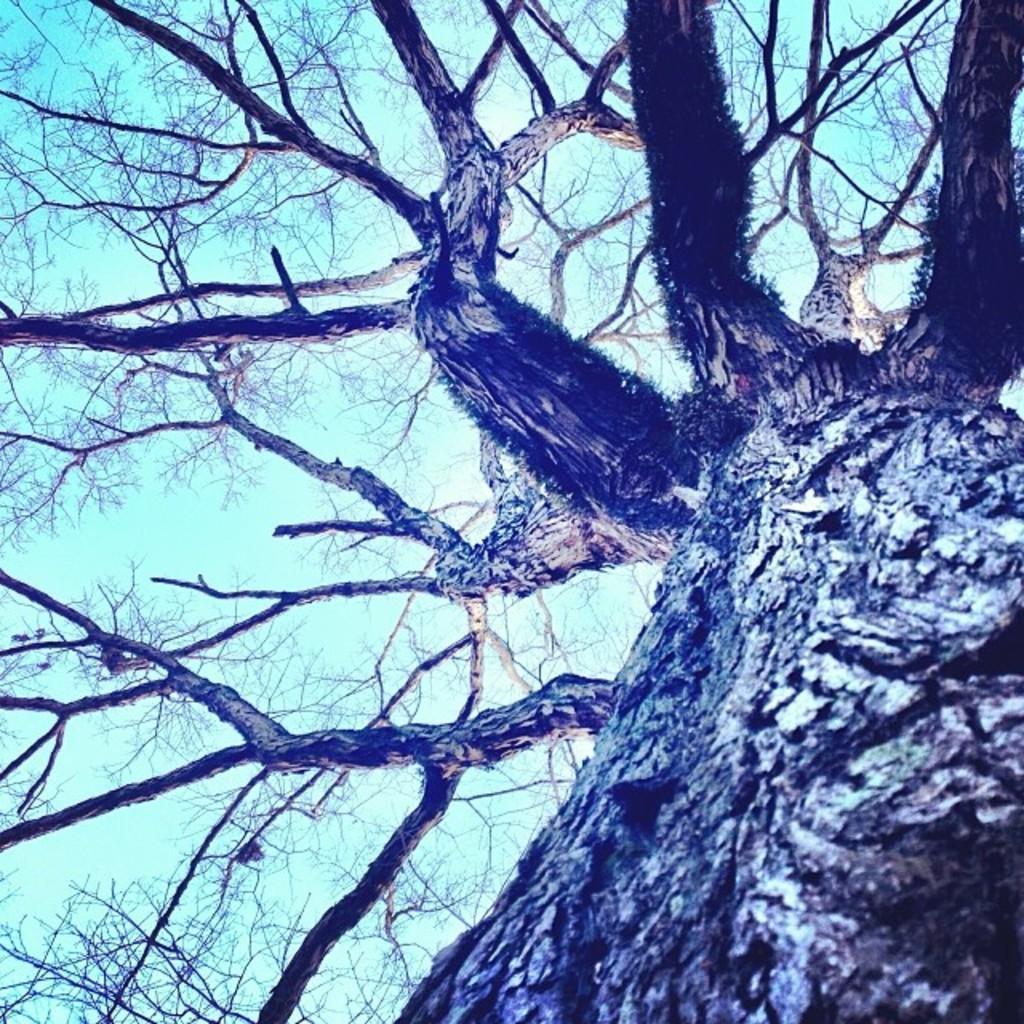Describe this image in one or two sentences. In the foreground of this image, there is a tree trunk and on the top, we can see the branches of the trees without leaves and the sky. 